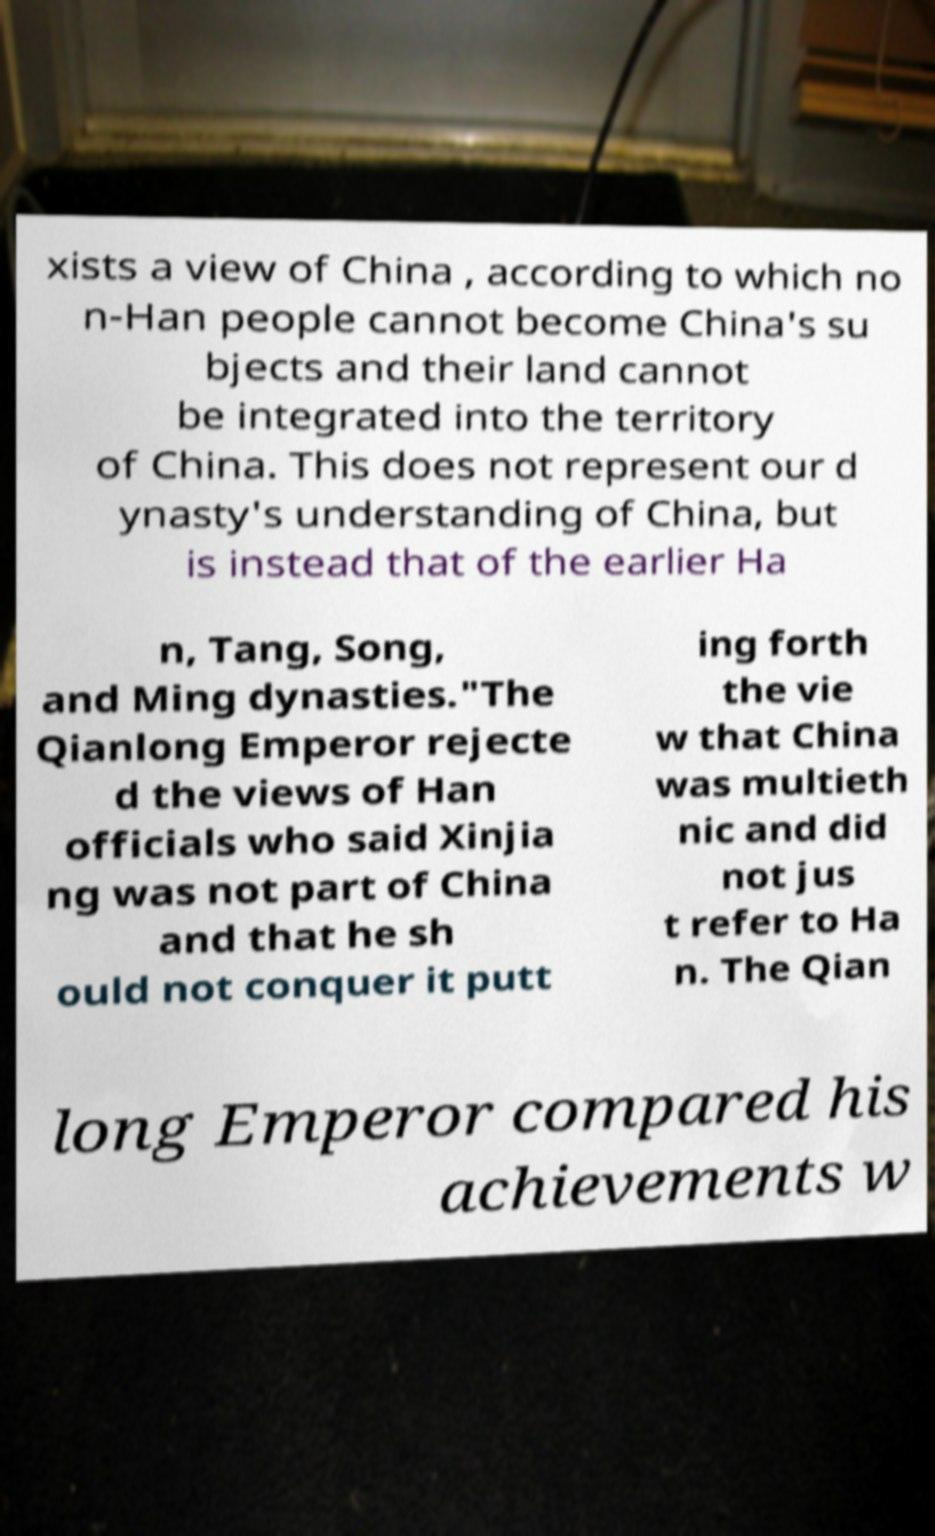For documentation purposes, I need the text within this image transcribed. Could you provide that? xists a view of China , according to which no n-Han people cannot become China's su bjects and their land cannot be integrated into the territory of China. This does not represent our d ynasty's understanding of China, but is instead that of the earlier Ha n, Tang, Song, and Ming dynasties."The Qianlong Emperor rejecte d the views of Han officials who said Xinjia ng was not part of China and that he sh ould not conquer it putt ing forth the vie w that China was multieth nic and did not jus t refer to Ha n. The Qian long Emperor compared his achievements w 